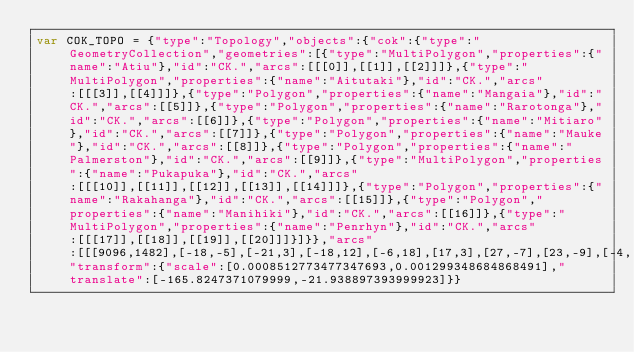Convert code to text. <code><loc_0><loc_0><loc_500><loc_500><_JavaScript_>var COK_TOPO = {"type":"Topology","objects":{"cok":{"type":"GeometryCollection","geometries":[{"type":"MultiPolygon","properties":{"name":"Atiu"},"id":"CK.","arcs":[[[0]],[[1]],[[2]]]},{"type":"MultiPolygon","properties":{"name":"Aitutaki"},"id":"CK.","arcs":[[[3]],[[4]]]},{"type":"Polygon","properties":{"name":"Mangaia"},"id":"CK.","arcs":[[5]]},{"type":"Polygon","properties":{"name":"Rarotonga"},"id":"CK.","arcs":[[6]]},{"type":"Polygon","properties":{"name":"Mitiaro"},"id":"CK.","arcs":[[7]]},{"type":"Polygon","properties":{"name":"Mauke"},"id":"CK.","arcs":[[8]]},{"type":"Polygon","properties":{"name":"Palmerston"},"id":"CK.","arcs":[[9]]},{"type":"MultiPolygon","properties":{"name":"Pukapuka"},"id":"CK.","arcs":[[[10]],[[11]],[[12]],[[13]],[[14]]]},{"type":"Polygon","properties":{"name":"Rakahanga"},"id":"CK.","arcs":[[15]]},{"type":"Polygon","properties":{"name":"Manihiki"},"id":"CK.","arcs":[[16]]},{"type":"MultiPolygon","properties":{"name":"Penrhyn"},"id":"CK.","arcs":[[[17]],[[18]],[[19]],[[20]]]}]}},"arcs":[[[9096,1482],[-18,-5],[-21,3],[-18,12],[-6,18],[17,3],[27,-7],[23,-9],[-4,-15]],[[8871,1626],[6,-5],[-15,8],[5,-1],[4,-2]],[[8847,1633],[-5,0],[2,2],[10,3],[-7,-5]],[[8090,2064],[7,-6],[16,3],[-1,-2],[-1,-2],[-6,-2],[-14,3],[-15,8],[-7,7],[12,2],[6,-4],[3,-7]],[[8136,2066],[-7,-4],[-7,4],[-1,4],[-6,3],[-1,2],[4,4],[12,-2],[6,-11]],[[9269,47],[15,-3],[13,-8],[24,-18],[3,-8],[-13,-6],[-20,-3],[-14,-1],[-18,1],[-12,4],[-9,7],[-9,8],[5,10],[10,9],[13,6],[12,2]],[[7080,579],[23,0],[23,-4],[19,-8],[7,-11],[0,-16],[-2,-7],[-6,-6],[-32,3],[-4,-1],[-23,8],[-47,-3],[-15,9],[9,5],[7,15],[1,9],[10,5],[30,2]],[[9535,1671],[-3,-16],[4,-21],[-2,-20],[-15,-11],[0,11],[-6,7],[-8,5],[-7,6],[-3,11],[5,6],[26,18],[9,4]],[[9999,1373],[-6,-13],[-12,-6],[-14,3],[-11,12],[1,13],[12,4],[16,-3],[14,-10]],[[7095,2392],[14,1],[13,-6],[1,-6],[-5,3],[-2,5],[-3,0],[-11,-14],[-1,-3],[4,-16],[-8,-8],[-12,0],[-9,8],[-1,9],[5,15],[5,5],[10,7]],[[3114,6663],[-3,0],[1,2],[2,-2]],[[3221,6682],[0,-1],[-2,2],[0,1],[2,-2]],[[484,7988],[0,-4],[-7,3],[0,4],[7,-3]],[[25,8459],[-14,-4],[-11,3],[2,2],[10,-1],[3,6],[8,1],[2,-7]],[[13,8504],[-6,-2],[-4,2],[-3,6],[10,1],[5,0],[5,-1],[-7,-6]],[[5564,9161],[21,6],[-6,-7],[-14,-6],[-1,7]],[[5684,8894],[-10,6],[-2,2],[19,-7],[49,-32],[-56,31]],[[9208,9883],[13,-13],[-5,1],[-37,36],[2,0],[27,-24]],[[9299,9931],[-2,-1],[-7,5],[-6,1],[-5,4],[-2,5],[1,1],[17,-11],[2,-2],[2,-2]],[[9157,9911],[-2,-2],[-7,3],[-32,35],[38,-35],[3,-1]],[[9261,9973],[-24,0],[-20,3],[-22,9],[-13,9],[6,5],[73,-21],[0,-5]]],"transform":{"scale":[0.0008512773477347693,0.001299348684868491],"translate":[-165.8247371079999,-21.938897393999923]}}</code> 